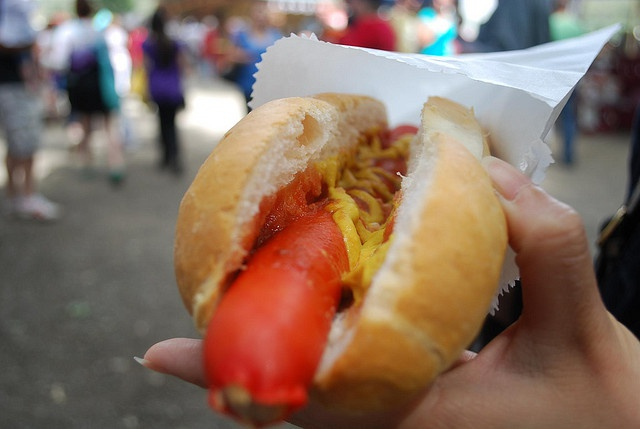Describe the objects in this image and their specific colors. I can see hot dog in gray, brown, tan, and maroon tones, people in gray, maroon, and brown tones, people in gray, darkgray, and black tones, people in gray, black, darkgray, and teal tones, and people in gray, black, navy, and purple tones in this image. 